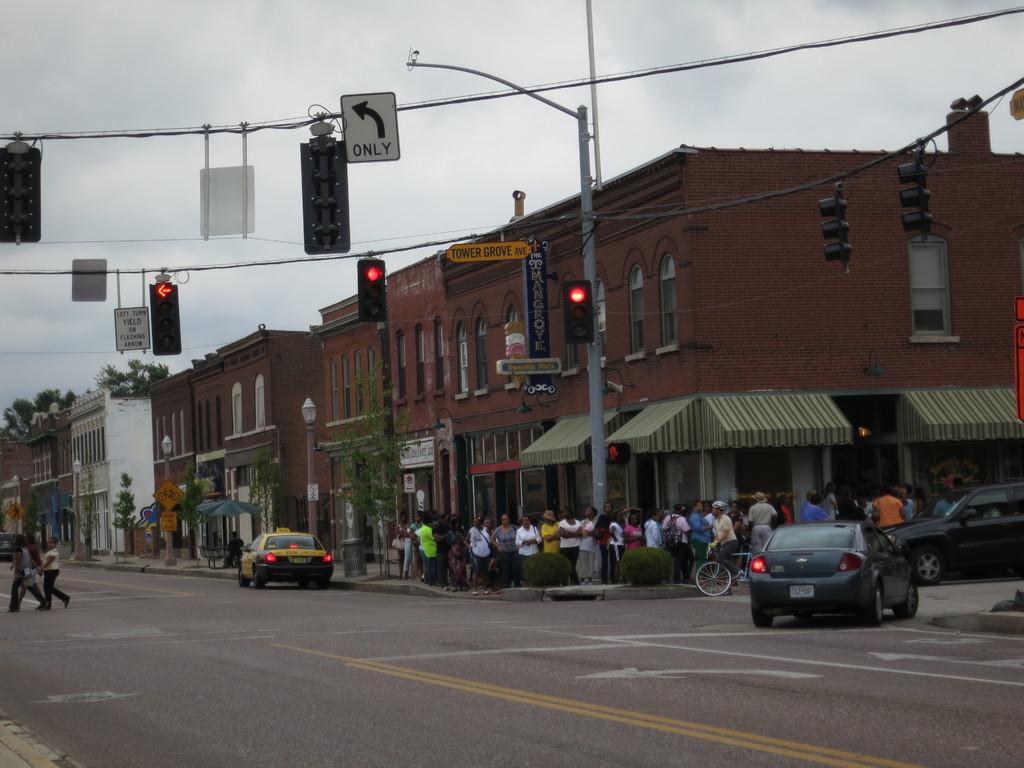How would you summarize this image in a sentence or two? In this image we can see the buildings and vehicles on the road. We can see some people standing. And we can see the traffic signals, sign boards and lights. We can see the plants and trees. At the top we can see the sky. 